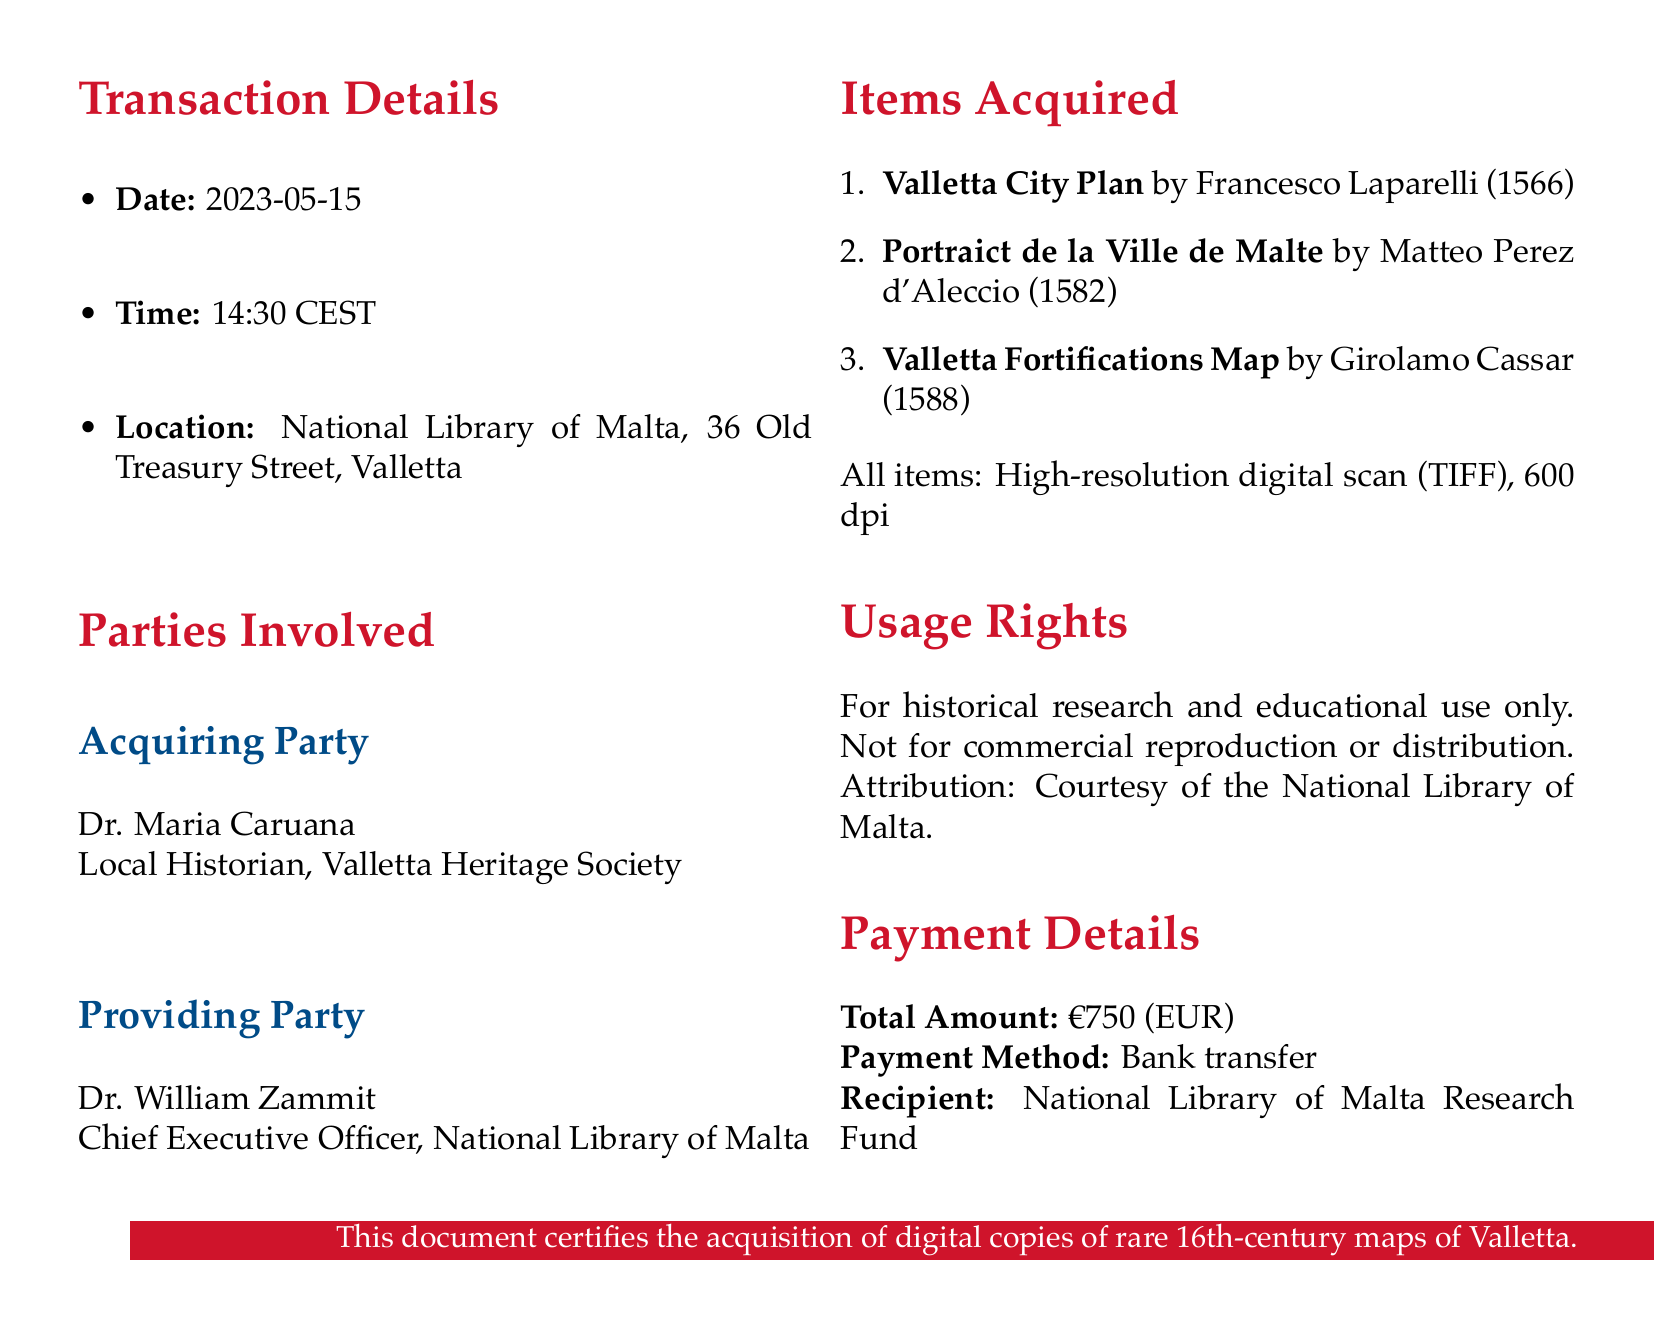What is the transaction ID? The transaction ID is specified in the document as a unique identifier for the transaction record.
Answer: NLM-DC-2023-056 Who is the acquiring party? The acquiring party is the individual or organization obtaining the digital copies of the maps, as stated in the parties involved section.
Answer: Dr. Maria Caruana What is the total amount paid? The total amount paid is mentioned under payment details, representing the cost of the transaction.
Answer: €750 What is the purpose of the acquired items? The purpose provided in the usage rights section indicates how the acquired items can be utilized.
Answer: Historical research and educational use What is the resolution of the digital scans? The resolution is specified for the digital scans of the maps acquired and reflects the quality of the scans.
Answer: 600 dpi What map was created by Matteo Perez d'Aleccio? The document lists the titles of the acquired maps, one of which was created by this individual.
Answer: Portraict de la Ville de Malte What are the confidentiality terms for the acquiring party? The document includes additional terms concerning confidentiality that the acquiring party must adhere to regarding the maps.
Answer: Maintain the confidentiality of any sensitive information When was the Valletta Fortifications Map created? The date of creation for this specific map is mentioned in the items acquired section of the document.
Answer: 1588 What is the file size of the Valletta City Plan? The document specifies the file size of this particular map, which indicates the storage requirement for the digital copy.
Answer: 1.2 GB 